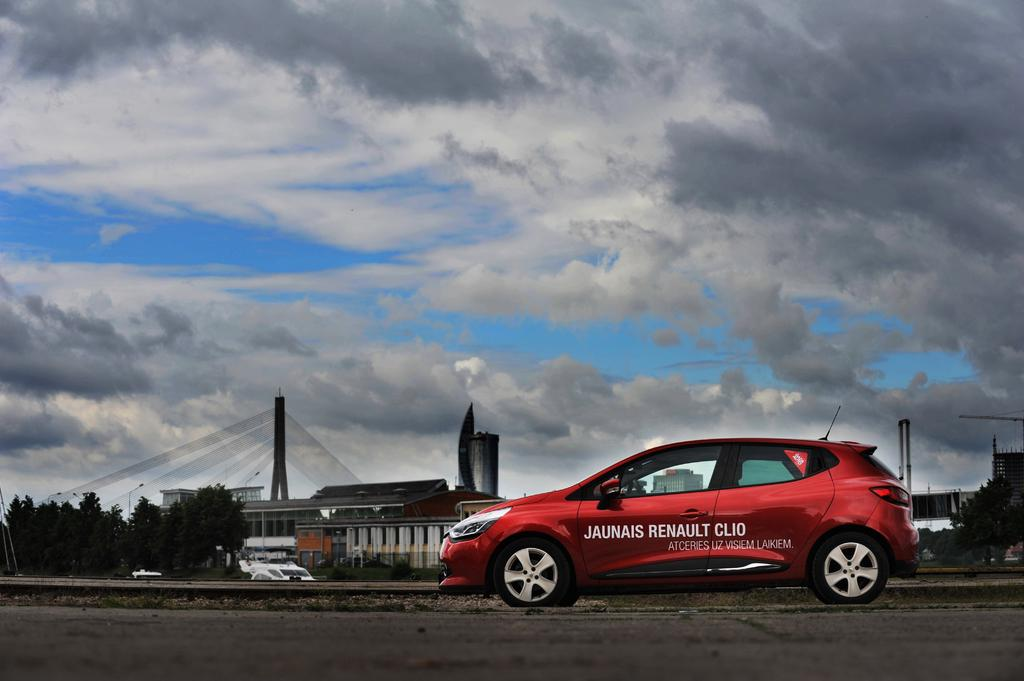What is the main subject of the image? The main subject of the image is a car. What can be seen on the car? The car has text on it. What can be seen in the background of the image? There are trees and buildings in the background of the image. What is visible at the top of the image? The sky is visible in the image, and there are clouds in the sky. What is at the bottom of the image? There is a road at the bottom of the image. How many cherries are hanging from the trees in the image? There are no cherries visible in the image; only trees and buildings can be seen in the background. What type of muscle is being exercised by the car in the image? The car is not exercising any muscles; it is a stationary object in the image. 